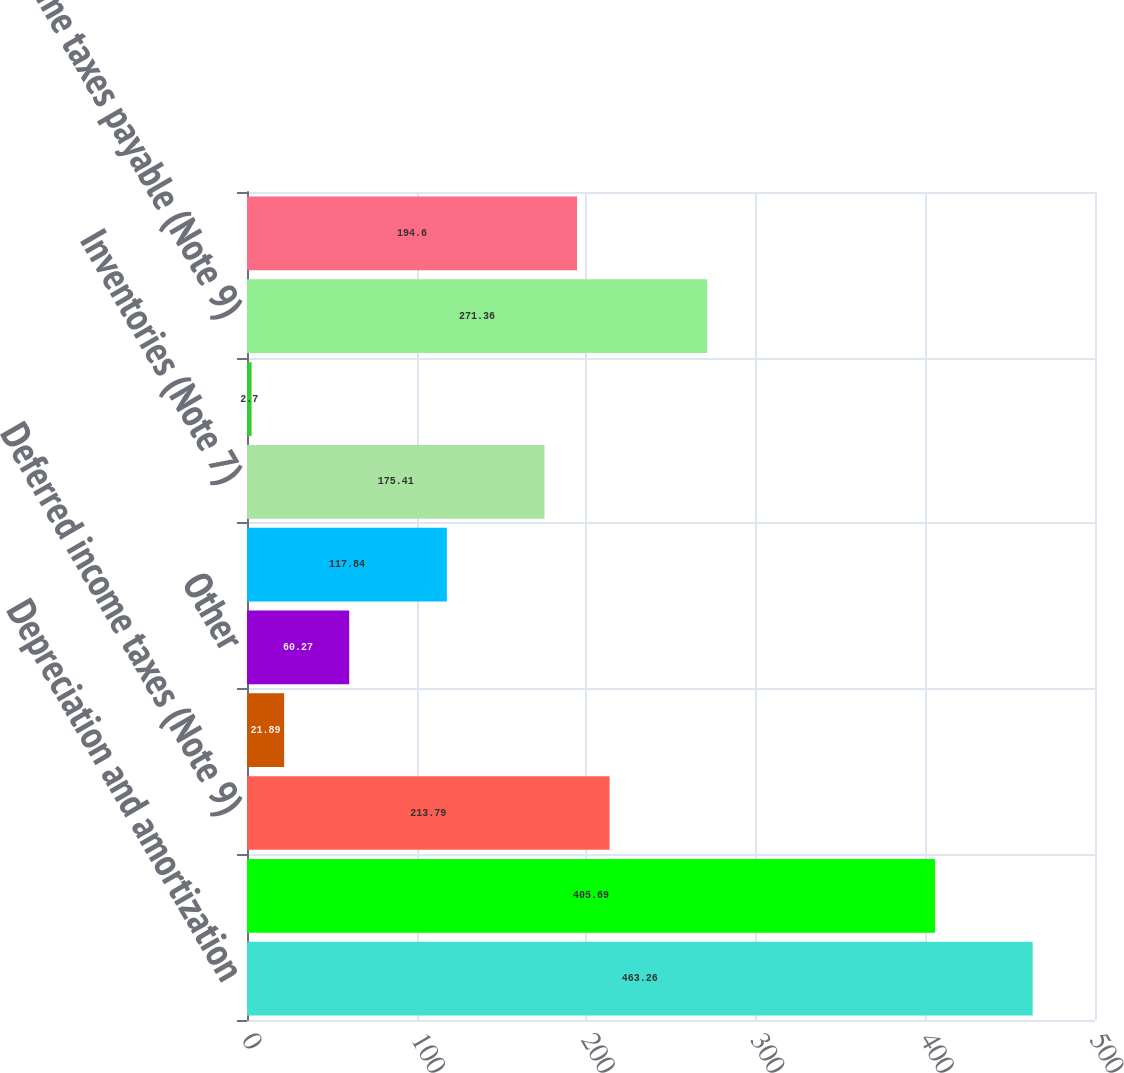<chart> <loc_0><loc_0><loc_500><loc_500><bar_chart><fcel>Depreciation and amortization<fcel>Equity in (earnings) loss of<fcel>Deferred income taxes (Note 9)<fcel>Minority interests<fcel>Other<fcel>Trade receivables net<fcel>Inventories (Note 7)<fcel>Other current assets and other<fcel>Income taxes payable (Note 9)<fcel>Accrued pension and other<nl><fcel>463.26<fcel>405.69<fcel>213.79<fcel>21.89<fcel>60.27<fcel>117.84<fcel>175.41<fcel>2.7<fcel>271.36<fcel>194.6<nl></chart> 